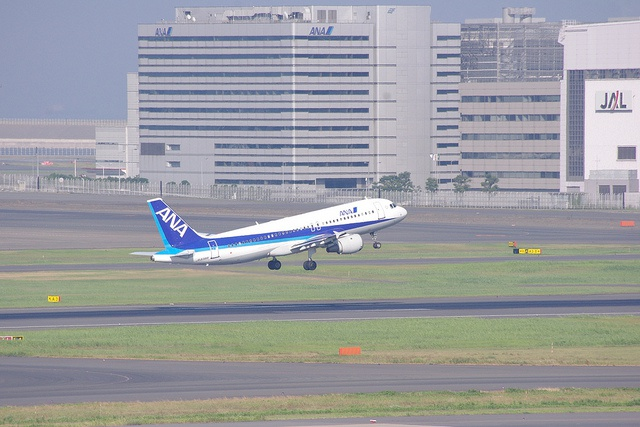Describe the objects in this image and their specific colors. I can see a airplane in darkgray, white, gray, and blue tones in this image. 